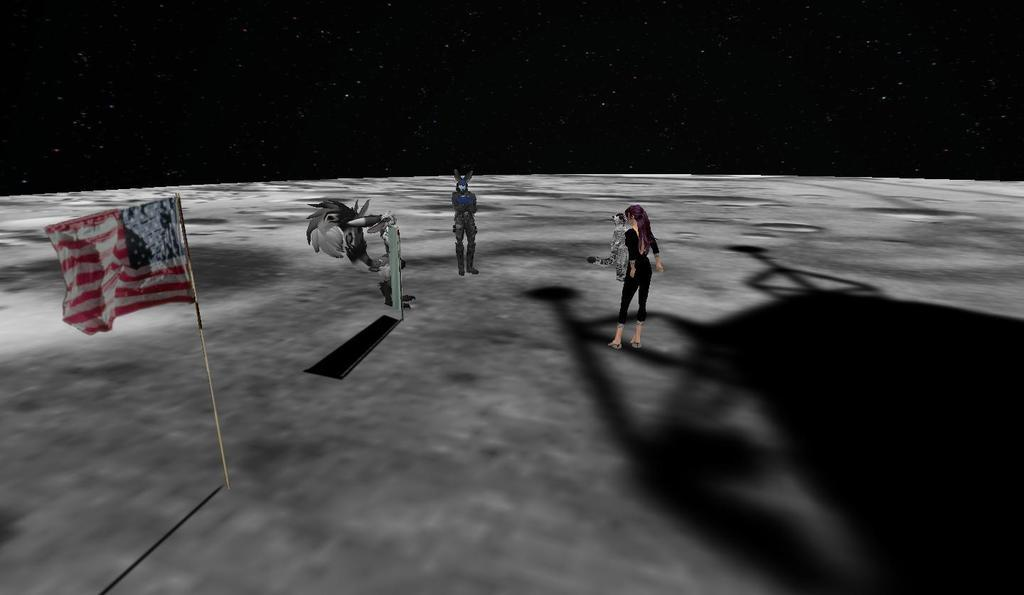What type of image is being described? The image is animated. What can be seen in the image besides the animated elements? There are animals in the image. What is hanging from a pole in the image? There is a flag hanging from a pole in the image. What is the woman doing in the image? The woman is standing on an astronomical object in the image. What is the background of the image? The background of the image is space. What does the writer's tongue look like in the image? There is no writer or tongue present in the image. How does the woman slip off the astronomical object in the image? The woman does not slip off the astronomical object in the image; she is standing on it. 